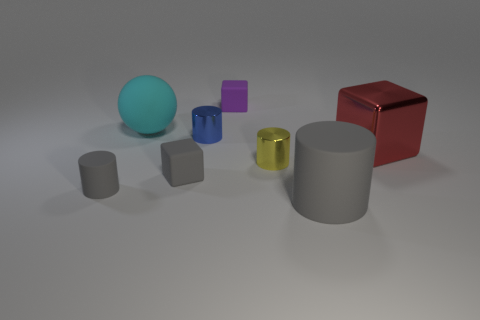Is there anything else that has the same shape as the purple object?
Keep it short and to the point. Yes. What number of cylinders are big blue things or large cyan matte things?
Make the answer very short. 0. What number of tiny cyan shiny spheres are there?
Your response must be concise. 0. What is the size of the gray cylinder that is in front of the gray cylinder that is to the left of the large rubber cylinder?
Your answer should be very brief. Large. How many other things are the same size as the purple cube?
Make the answer very short. 4. How many cylinders are in front of the red shiny block?
Ensure brevity in your answer.  3. What is the size of the yellow object?
Keep it short and to the point. Small. Do the block left of the tiny purple rubber cube and the small purple object right of the rubber ball have the same material?
Offer a very short reply. Yes. Are there any tiny metal cylinders that have the same color as the big shiny thing?
Give a very brief answer. No. What is the color of the metal block that is the same size as the cyan sphere?
Your answer should be very brief. Red. 